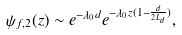<formula> <loc_0><loc_0><loc_500><loc_500>\psi _ { f , 2 } ( z ) \sim e ^ { - \lambda _ { 0 } d } e ^ { - \lambda _ { 0 } z ( 1 - \frac { d } { 2 L _ { d } } ) } ,</formula> 